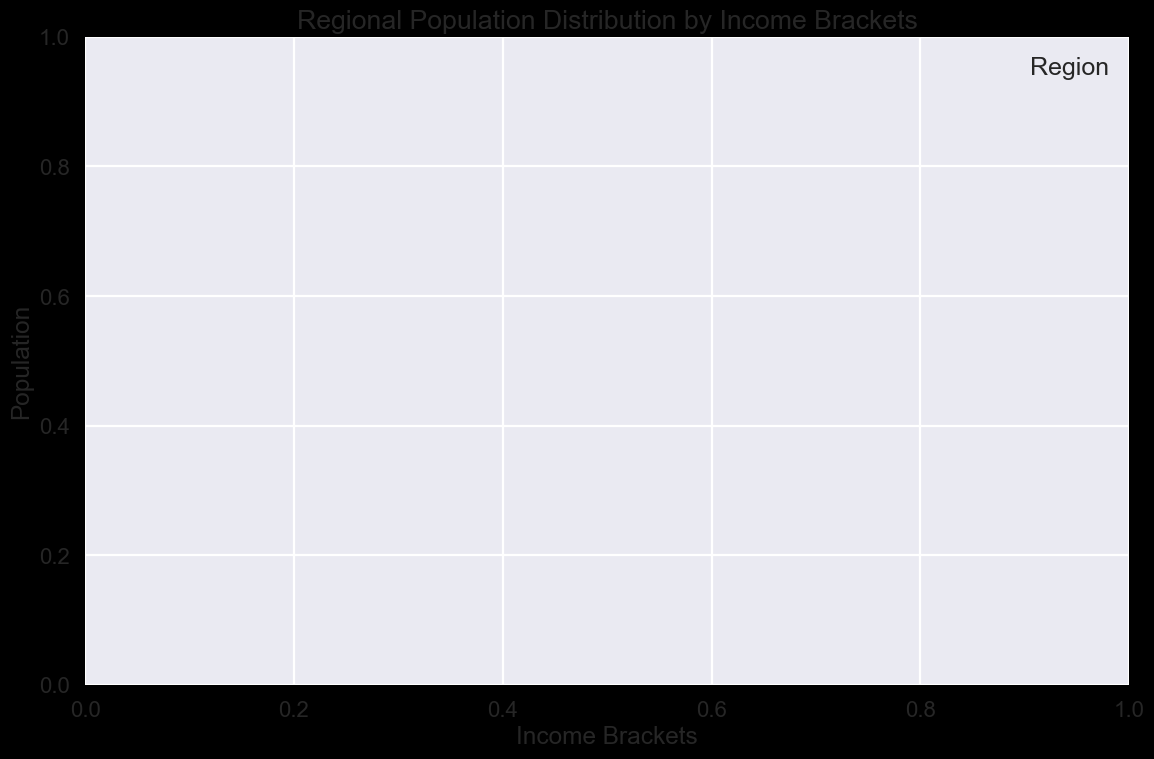What's the most prevalent income bracket in Region A? Look at the highest bar or peak in Region A's histogram. The corresponding income bracket is the most prevalent.
Answer: [Answer based on figure] Compare the median income bracket for Region B and Region C. Which one is higher? Estimate the midpoint of the data distribution in the histogram for both Region B and Region C. Identify the income bracket at the median for each. Compare the two incomes to determine which is higher.
Answer: [Answer based on figure] Which region has the broadest spread of income brackets? Observe the width of the distribution for each region's histogram. The one with the widest range of bars (from the lowest to the highest income bracket) has the broadest spread.
Answer: [Answer based on figure] For Region D, is the population more concentrated in higher or lower income brackets? Check the skewness of Region D's histogram. If more bars are towards the higher income brackets, the population is concentrated in higher income brackets. Otherwise, it's concentrated in lower income brackets.
Answer: [Answer based on figure] Is there any region where the population distribution is roughly uniform across different income brackets? Look for regions where the bars in the histogram are approximately the same height across all income brackets, indicating a roughly uniform distribution.
Answer: [Answer based on figure] Which region has the highest population in the lowest income bracket? Identify the bar representing the lowest income bracket for each region. Compare their heights and find the highest one.
Answer: [Answer based on figure] Does Region E have outliers in its income distribution? Outliers are indicated by bars that are significantly higher or lower compared to the neighboring bars in Region E's histogram. Look for these irregularities.
Answer: [Answer based on figure] Between Region F and Region G, which one has a more evenly distributed population across income brackets? Compare the smoothness of the histograms for Region F and Region G. The region with a more even height of bars indicates a more evenly distributed population.
Answer: [Answer based on figure] Summing up the populations, do Region A and Region B together have more people in the middle-income brackets than Region C? Add the populations in the middle-income brackets for both Region A and Region B from their histograms. Compare this sum to the total population in the middle-income brackets for Region C.
Answer: [Answer based on figure] Which region shows a significant clustering of population around a specific income bracket? Identify regions where one or more bars are noticeably taller than all others, indicating a significant clustering around those income brackets.
Answer: [Answer based on figure] 